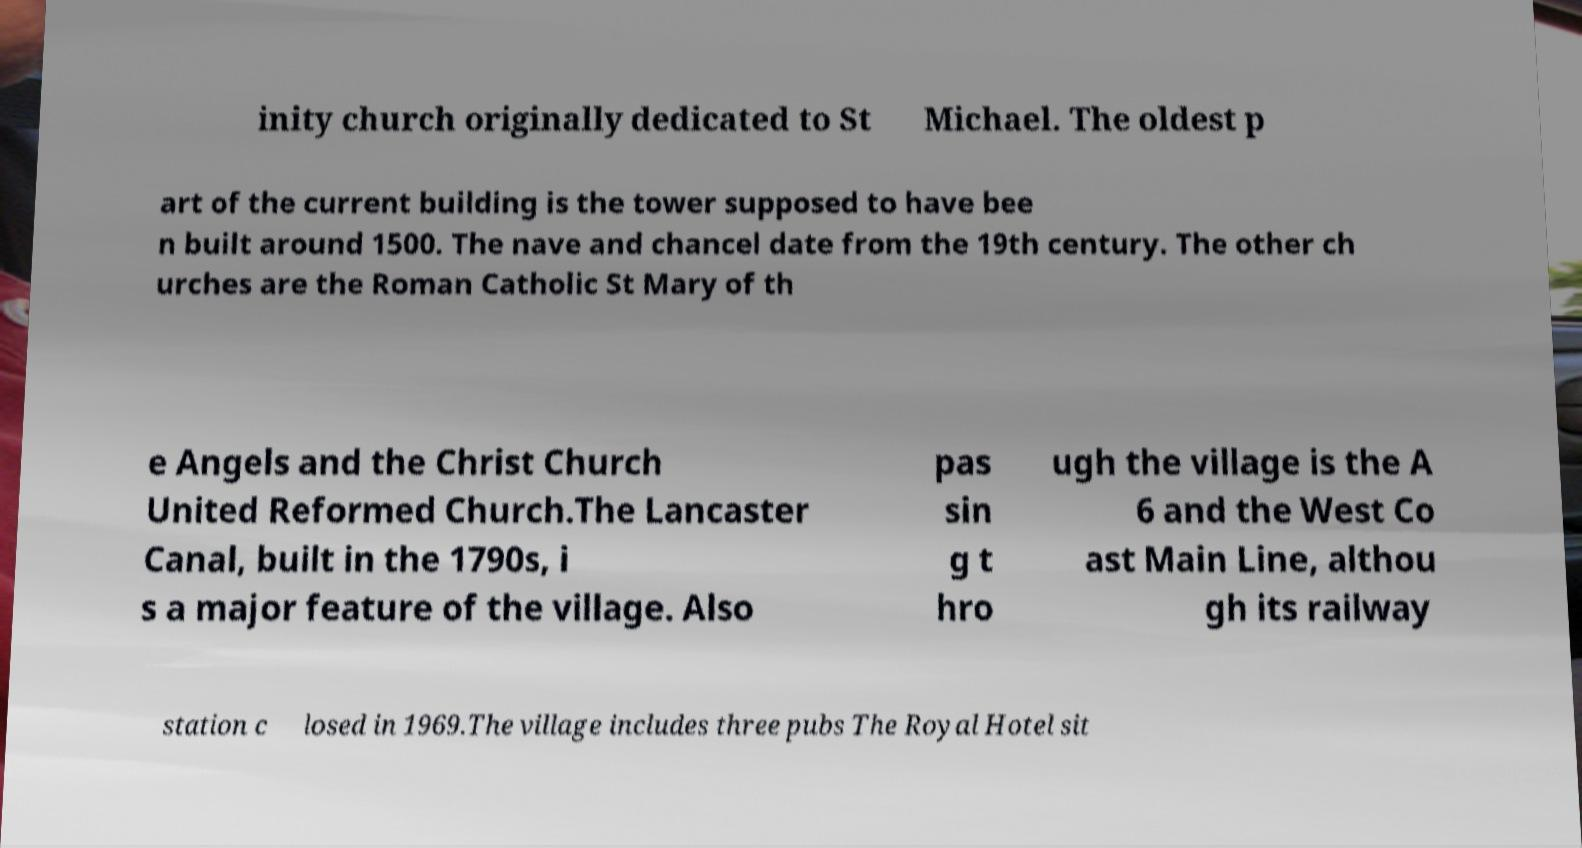Can you accurately transcribe the text from the provided image for me? inity church originally dedicated to St Michael. The oldest p art of the current building is the tower supposed to have bee n built around 1500. The nave and chancel date from the 19th century. The other ch urches are the Roman Catholic St Mary of th e Angels and the Christ Church United Reformed Church.The Lancaster Canal, built in the 1790s, i s a major feature of the village. Also pas sin g t hro ugh the village is the A 6 and the West Co ast Main Line, althou gh its railway station c losed in 1969.The village includes three pubs The Royal Hotel sit 